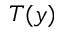<formula> <loc_0><loc_0><loc_500><loc_500>T ( y )</formula> 